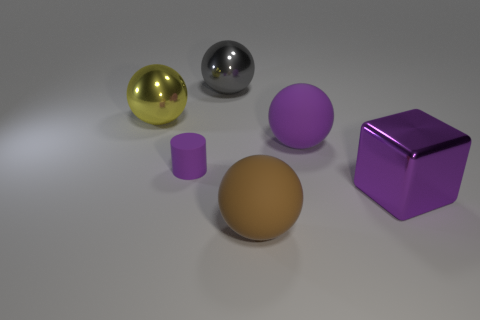Is the color of the cylinder the same as the cube?
Give a very brief answer. Yes. What number of objects are there?
Provide a short and direct response. 6. Is the thing behind the big yellow metallic ball made of the same material as the large ball that is in front of the purple ball?
Make the answer very short. No. What color is the other shiny thing that is the same shape as the gray shiny thing?
Offer a very short reply. Yellow. What is the material of the big cube right of the big rubber thing to the right of the brown matte thing?
Your answer should be compact. Metal. There is a gray object that is on the right side of the tiny purple matte object; is it the same shape as the matte object behind the tiny object?
Offer a very short reply. Yes. How big is the sphere that is both right of the tiny purple cylinder and on the left side of the brown rubber thing?
Provide a short and direct response. Large. How many other things are there of the same color as the small rubber cylinder?
Offer a very short reply. 2. Is the object behind the large yellow object made of the same material as the purple cube?
Your answer should be compact. Yes. Are there any other things that are the same size as the yellow shiny thing?
Offer a very short reply. Yes. 